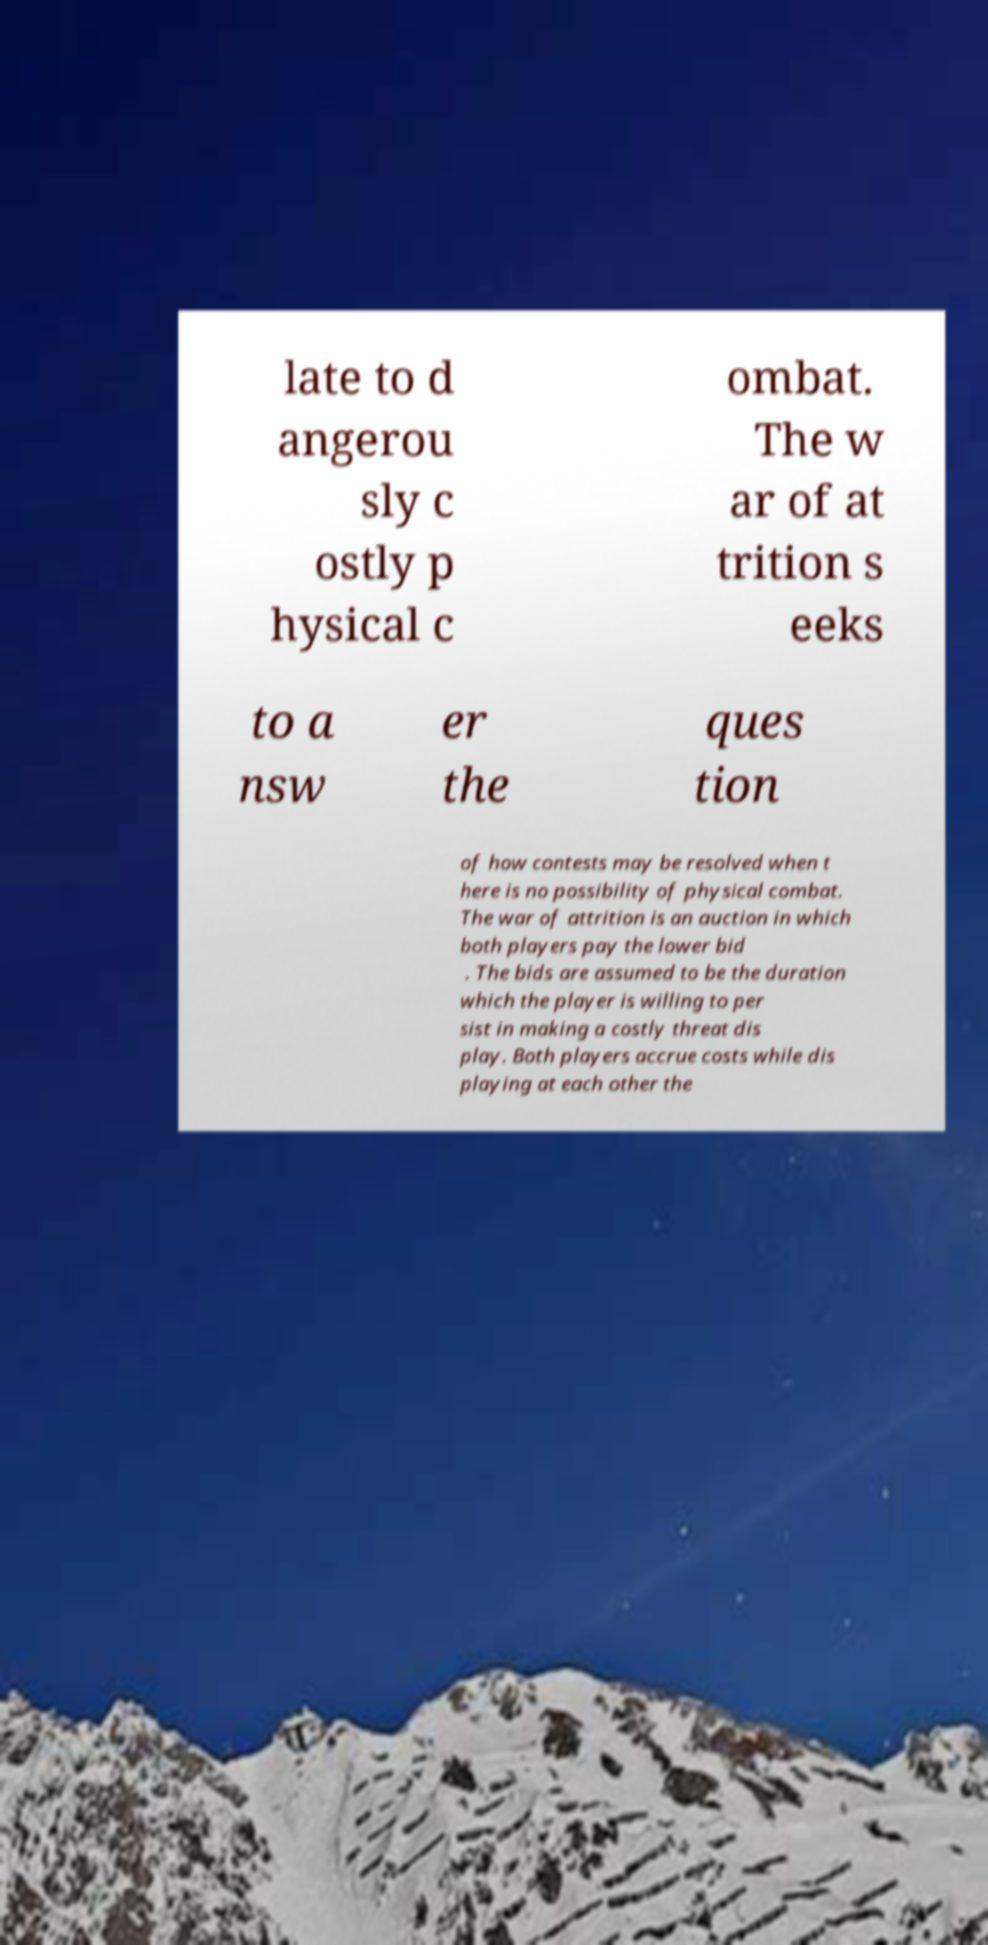There's text embedded in this image that I need extracted. Can you transcribe it verbatim? late to d angerou sly c ostly p hysical c ombat. The w ar of at trition s eeks to a nsw er the ques tion of how contests may be resolved when t here is no possibility of physical combat. The war of attrition is an auction in which both players pay the lower bid . The bids are assumed to be the duration which the player is willing to per sist in making a costly threat dis play. Both players accrue costs while dis playing at each other the 